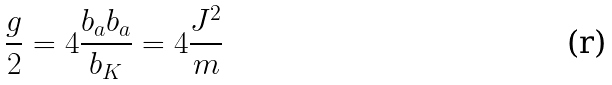Convert formula to latex. <formula><loc_0><loc_0><loc_500><loc_500>\frac { g } { 2 } = 4 \frac { b _ { a } b _ { a } } { b _ { K } } = 4 \frac { J ^ { 2 } } { m }</formula> 